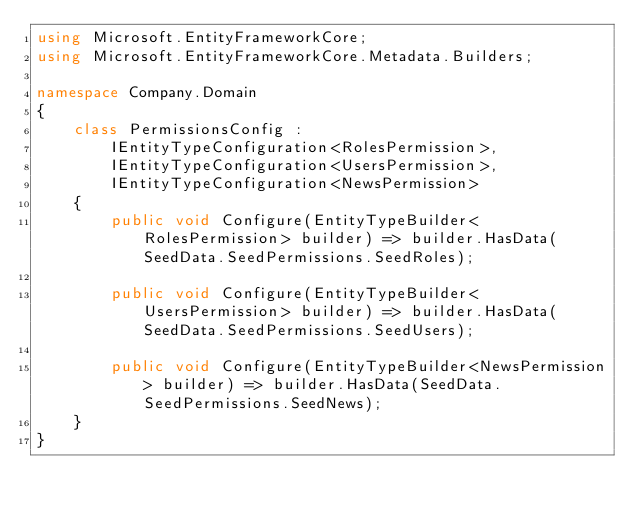Convert code to text. <code><loc_0><loc_0><loc_500><loc_500><_C#_>using Microsoft.EntityFrameworkCore;
using Microsoft.EntityFrameworkCore.Metadata.Builders;

namespace Company.Domain
{
    class PermissionsConfig :
        IEntityTypeConfiguration<RolesPermission>,
        IEntityTypeConfiguration<UsersPermission>,
        IEntityTypeConfiguration<NewsPermission>
    {
        public void Configure(EntityTypeBuilder<RolesPermission> builder) => builder.HasData(SeedData.SeedPermissions.SeedRoles);

        public void Configure(EntityTypeBuilder<UsersPermission> builder) => builder.HasData(SeedData.SeedPermissions.SeedUsers);

        public void Configure(EntityTypeBuilder<NewsPermission> builder) => builder.HasData(SeedData.SeedPermissions.SeedNews);
    }
}
</code> 